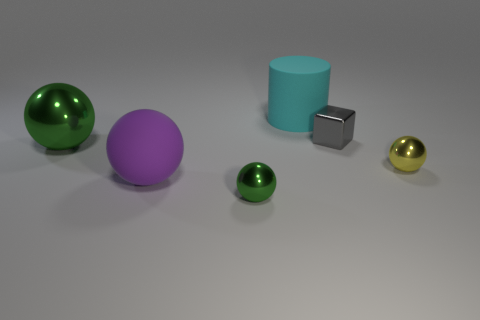What size is the other shiny thing that is the same color as the big metal thing?
Offer a terse response. Small. How many green balls are behind the ball that is to the left of the big purple ball?
Offer a very short reply. 0. What number of other objects are there of the same size as the matte sphere?
Your answer should be very brief. 2. Does the big cylinder have the same color as the large shiny object?
Your answer should be very brief. No. Is the shape of the matte object to the left of the rubber cylinder the same as  the gray metal object?
Your answer should be very brief. No. What number of things are behind the large purple matte object and on the left side of the large cyan matte object?
Make the answer very short. 1. What is the material of the purple object?
Give a very brief answer. Rubber. Is there anything else that has the same color as the small block?
Give a very brief answer. No. Is the tiny gray cube made of the same material as the large green thing?
Provide a succinct answer. Yes. There is a green ball to the left of the large rubber object left of the cylinder; what number of small metallic objects are left of it?
Your response must be concise. 0. 